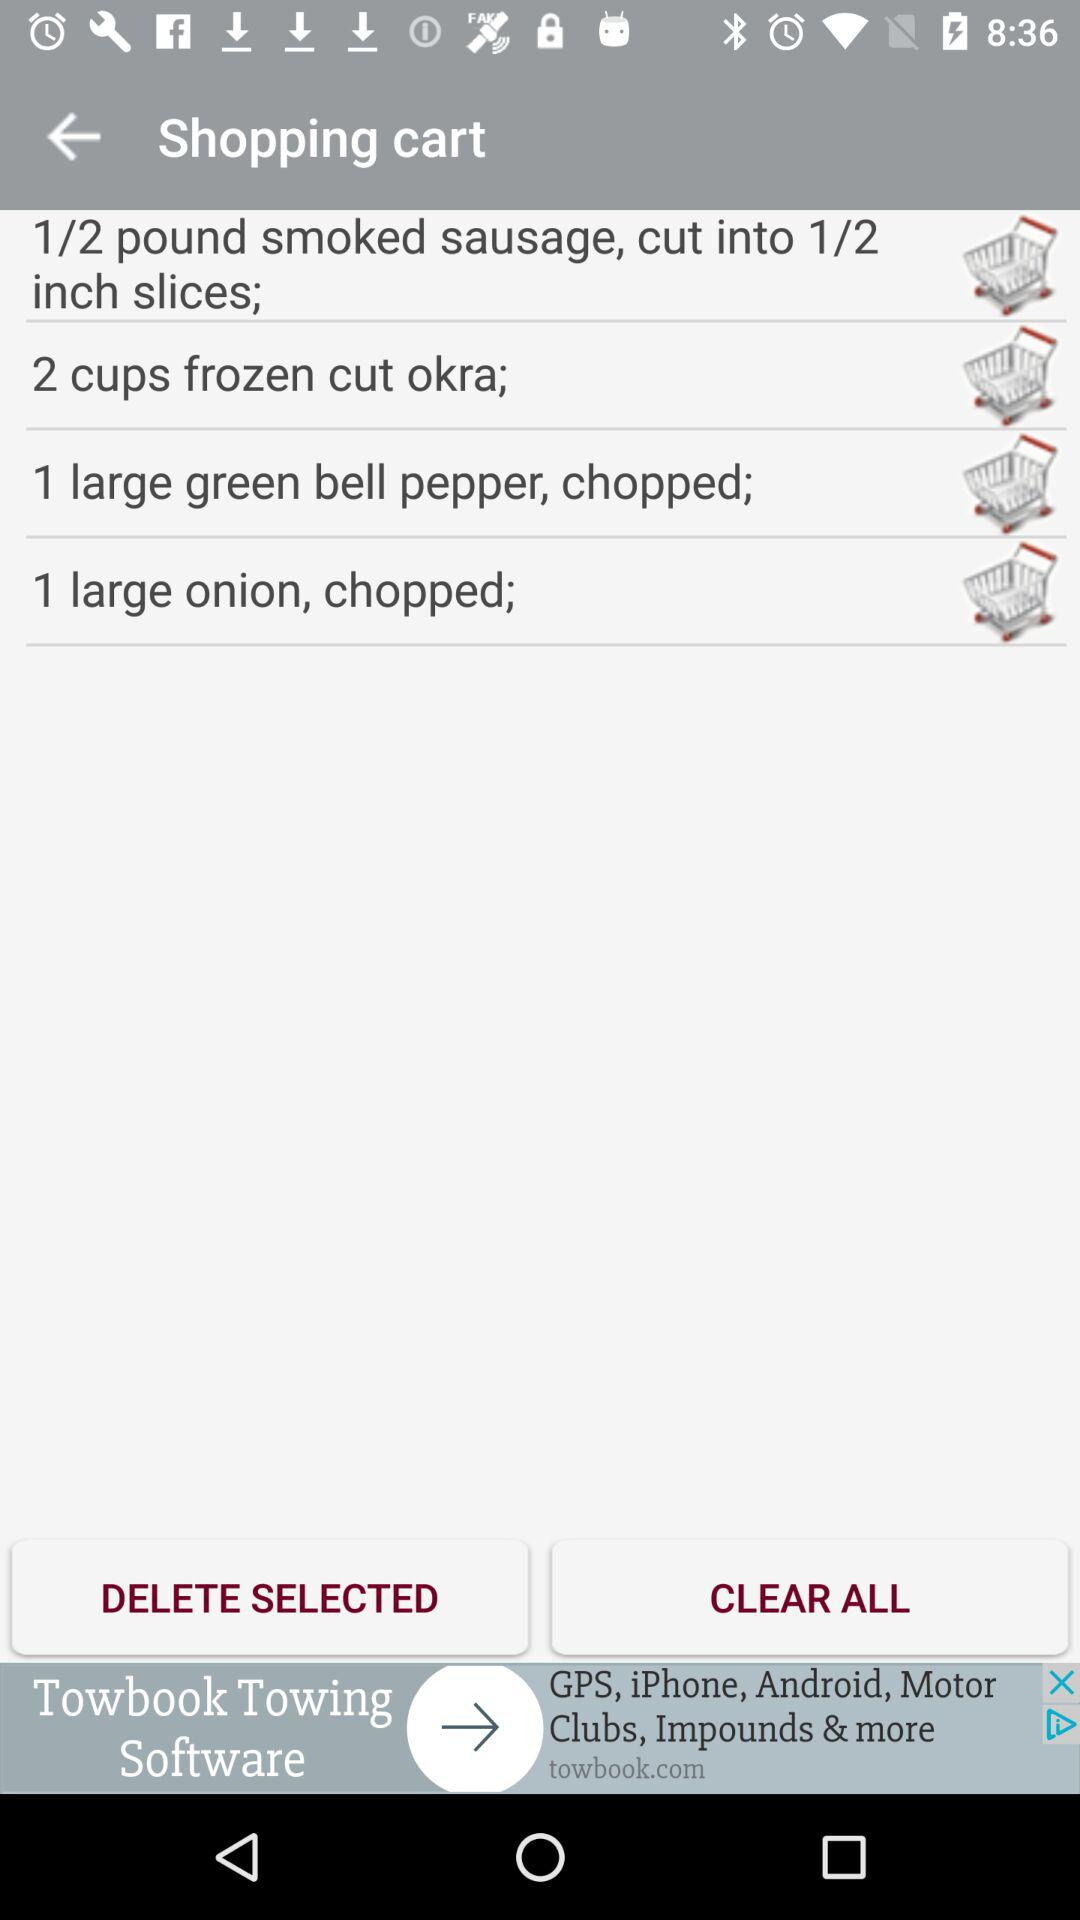How many items are in the shopping cart that are less than 2 cups?
Answer the question using a single word or phrase. 3 